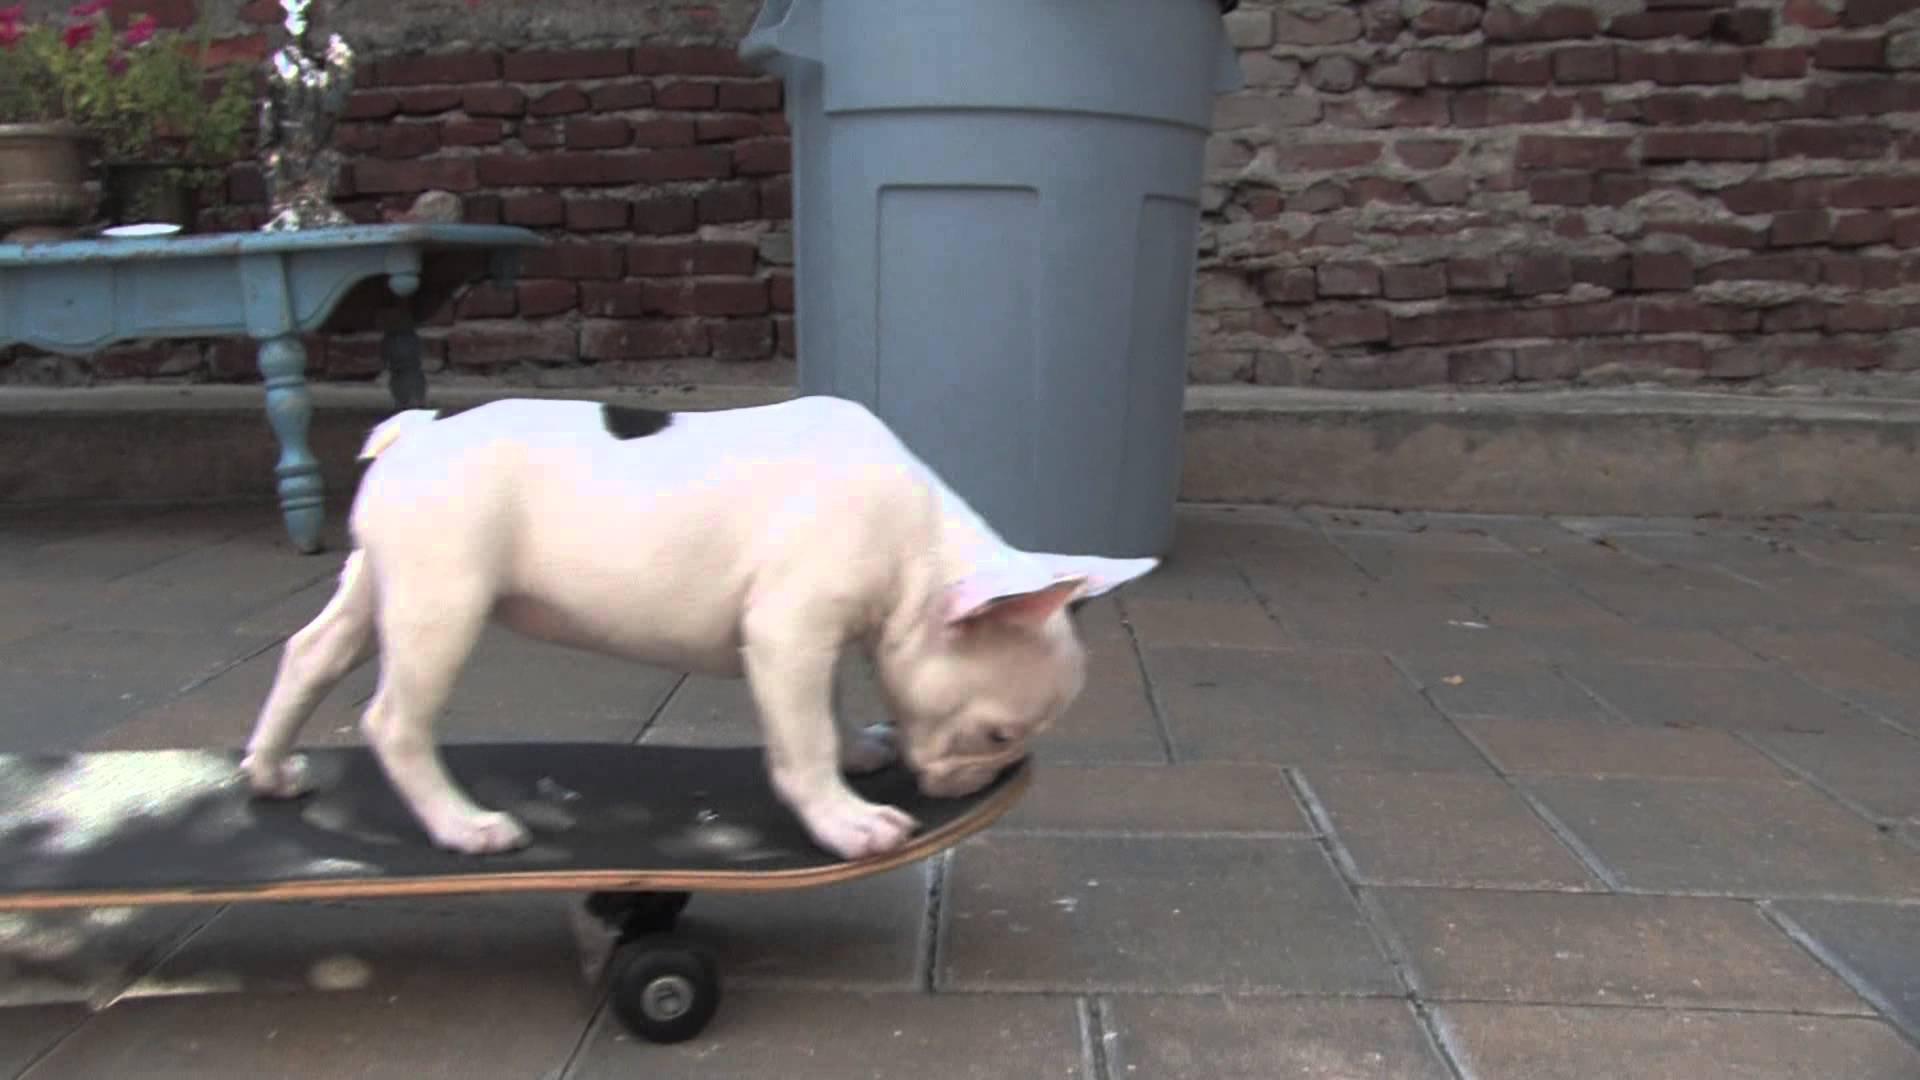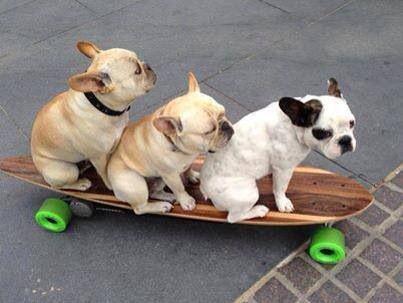The first image is the image on the left, the second image is the image on the right. Considering the images on both sides, is "At least one image features more than one dog on a skateboard." valid? Answer yes or no. Yes. The first image is the image on the left, the second image is the image on the right. For the images shown, is this caption "A small dog is perched on a black skateboard with black wheels." true? Answer yes or no. Yes. 